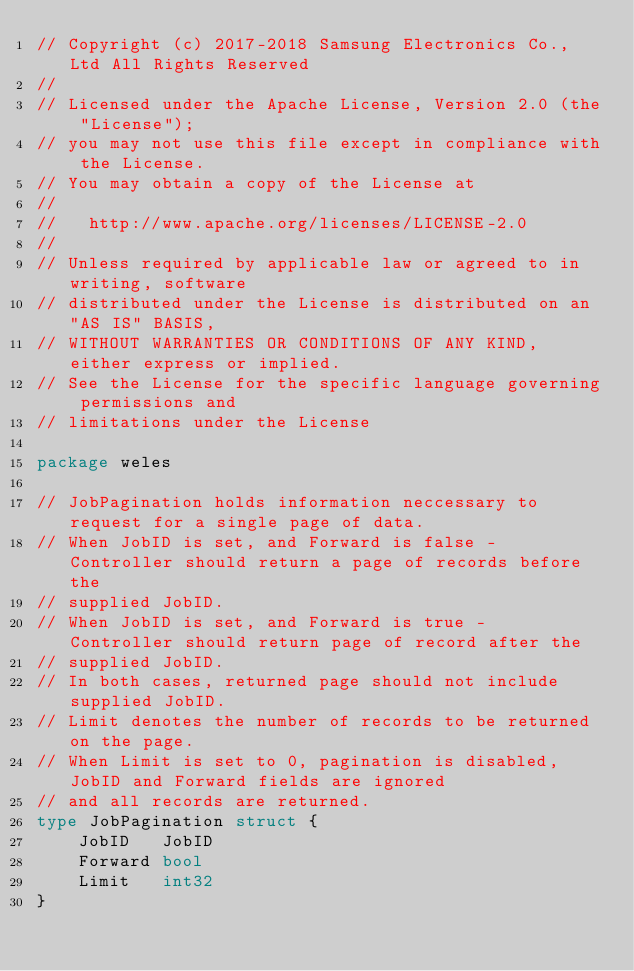<code> <loc_0><loc_0><loc_500><loc_500><_Go_>// Copyright (c) 2017-2018 Samsung Electronics Co., Ltd All Rights Reserved
//
// Licensed under the Apache License, Version 2.0 (the "License");
// you may not use this file except in compliance with the License.
// You may obtain a copy of the License at
//
//   http://www.apache.org/licenses/LICENSE-2.0
//
// Unless required by applicable law or agreed to in writing, software
// distributed under the License is distributed on an "AS IS" BASIS,
// WITHOUT WARRANTIES OR CONDITIONS OF ANY KIND, either express or implied.
// See the License for the specific language governing permissions and
// limitations under the License

package weles

// JobPagination holds information neccessary to request for a single page of data.
// When JobID is set, and Forward is false - Controller should return a page of records before the
// supplied JobID.
// When JobID is set, and Forward is true -  Controller should return page of record after the
// supplied JobID.
// In both cases, returned page should not include supplied JobID.
// Limit denotes the number of records to be returned on the page.
// When Limit is set to 0, pagination is disabled, JobID and Forward fields are ignored
// and all records are returned.
type JobPagination struct {
	JobID   JobID
	Forward bool
	Limit   int32
}
</code> 